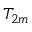<formula> <loc_0><loc_0><loc_500><loc_500>T _ { 2 m }</formula> 